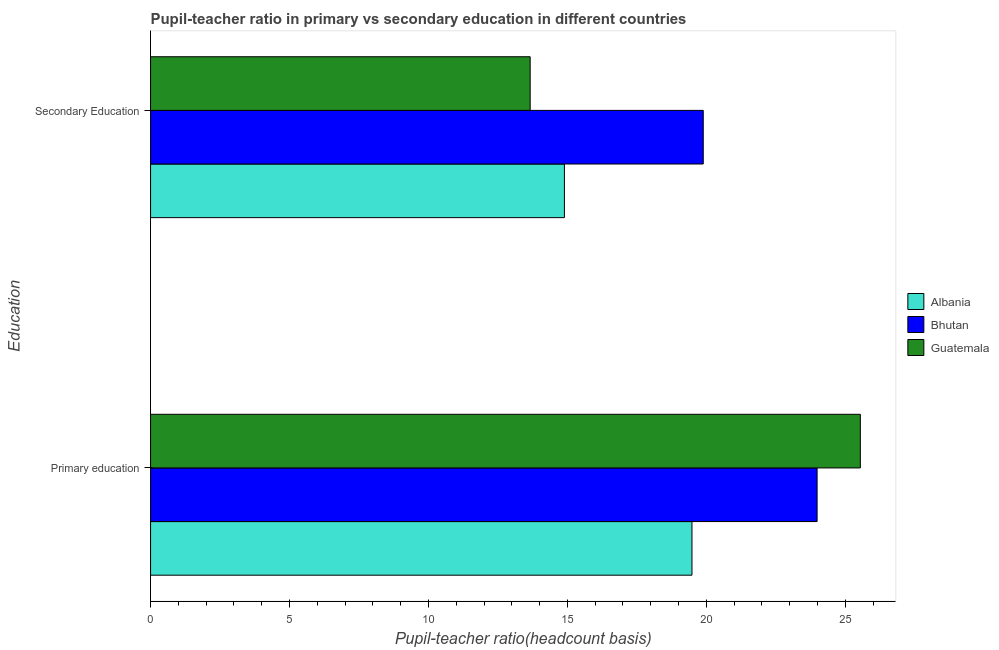How many groups of bars are there?
Your answer should be compact. 2. How many bars are there on the 1st tick from the top?
Your answer should be very brief. 3. What is the label of the 1st group of bars from the top?
Keep it short and to the point. Secondary Education. What is the pupil-teacher ratio in primary education in Albania?
Your answer should be compact. 19.48. Across all countries, what is the maximum pupil-teacher ratio in primary education?
Provide a succinct answer. 25.54. Across all countries, what is the minimum pupil teacher ratio on secondary education?
Your answer should be very brief. 13.66. In which country was the pupil-teacher ratio in primary education maximum?
Provide a succinct answer. Guatemala. In which country was the pupil-teacher ratio in primary education minimum?
Your response must be concise. Albania. What is the total pupil teacher ratio on secondary education in the graph?
Your answer should be compact. 48.44. What is the difference between the pupil teacher ratio on secondary education in Guatemala and that in Albania?
Your answer should be compact. -1.23. What is the difference between the pupil-teacher ratio in primary education in Albania and the pupil teacher ratio on secondary education in Bhutan?
Offer a very short reply. -0.41. What is the average pupil-teacher ratio in primary education per country?
Ensure brevity in your answer.  23. What is the difference between the pupil-teacher ratio in primary education and pupil teacher ratio on secondary education in Albania?
Offer a terse response. 4.59. In how many countries, is the pupil teacher ratio on secondary education greater than 16 ?
Your answer should be very brief. 1. What is the ratio of the pupil teacher ratio on secondary education in Guatemala to that in Bhutan?
Make the answer very short. 0.69. Is the pupil-teacher ratio in primary education in Guatemala less than that in Albania?
Ensure brevity in your answer.  No. What does the 3rd bar from the top in Secondary Education represents?
Offer a terse response. Albania. What does the 2nd bar from the bottom in Primary education represents?
Give a very brief answer. Bhutan. How many bars are there?
Your response must be concise. 6. Are all the bars in the graph horizontal?
Ensure brevity in your answer.  Yes. What is the difference between two consecutive major ticks on the X-axis?
Keep it short and to the point. 5. Are the values on the major ticks of X-axis written in scientific E-notation?
Give a very brief answer. No. Does the graph contain any zero values?
Provide a short and direct response. No. Does the graph contain grids?
Keep it short and to the point. No. How many legend labels are there?
Keep it short and to the point. 3. What is the title of the graph?
Your response must be concise. Pupil-teacher ratio in primary vs secondary education in different countries. Does "Tajikistan" appear as one of the legend labels in the graph?
Make the answer very short. No. What is the label or title of the X-axis?
Keep it short and to the point. Pupil-teacher ratio(headcount basis). What is the label or title of the Y-axis?
Your answer should be very brief. Education. What is the Pupil-teacher ratio(headcount basis) of Albania in Primary education?
Provide a succinct answer. 19.48. What is the Pupil-teacher ratio(headcount basis) of Bhutan in Primary education?
Provide a short and direct response. 23.99. What is the Pupil-teacher ratio(headcount basis) of Guatemala in Primary education?
Provide a succinct answer. 25.54. What is the Pupil-teacher ratio(headcount basis) of Albania in Secondary Education?
Your response must be concise. 14.89. What is the Pupil-teacher ratio(headcount basis) of Bhutan in Secondary Education?
Your answer should be very brief. 19.89. What is the Pupil-teacher ratio(headcount basis) in Guatemala in Secondary Education?
Ensure brevity in your answer.  13.66. Across all Education, what is the maximum Pupil-teacher ratio(headcount basis) of Albania?
Keep it short and to the point. 19.48. Across all Education, what is the maximum Pupil-teacher ratio(headcount basis) of Bhutan?
Provide a short and direct response. 23.99. Across all Education, what is the maximum Pupil-teacher ratio(headcount basis) of Guatemala?
Make the answer very short. 25.54. Across all Education, what is the minimum Pupil-teacher ratio(headcount basis) of Albania?
Make the answer very short. 14.89. Across all Education, what is the minimum Pupil-teacher ratio(headcount basis) of Bhutan?
Your answer should be compact. 19.89. Across all Education, what is the minimum Pupil-teacher ratio(headcount basis) in Guatemala?
Offer a very short reply. 13.66. What is the total Pupil-teacher ratio(headcount basis) of Albania in the graph?
Your answer should be compact. 34.38. What is the total Pupil-teacher ratio(headcount basis) in Bhutan in the graph?
Keep it short and to the point. 43.88. What is the total Pupil-teacher ratio(headcount basis) of Guatemala in the graph?
Your answer should be compact. 39.2. What is the difference between the Pupil-teacher ratio(headcount basis) in Albania in Primary education and that in Secondary Education?
Your response must be concise. 4.59. What is the difference between the Pupil-teacher ratio(headcount basis) of Bhutan in Primary education and that in Secondary Education?
Ensure brevity in your answer.  4.1. What is the difference between the Pupil-teacher ratio(headcount basis) in Guatemala in Primary education and that in Secondary Education?
Provide a short and direct response. 11.88. What is the difference between the Pupil-teacher ratio(headcount basis) of Albania in Primary education and the Pupil-teacher ratio(headcount basis) of Bhutan in Secondary Education?
Provide a succinct answer. -0.41. What is the difference between the Pupil-teacher ratio(headcount basis) in Albania in Primary education and the Pupil-teacher ratio(headcount basis) in Guatemala in Secondary Education?
Offer a very short reply. 5.82. What is the difference between the Pupil-teacher ratio(headcount basis) of Bhutan in Primary education and the Pupil-teacher ratio(headcount basis) of Guatemala in Secondary Education?
Offer a terse response. 10.33. What is the average Pupil-teacher ratio(headcount basis) of Albania per Education?
Your response must be concise. 17.19. What is the average Pupil-teacher ratio(headcount basis) of Bhutan per Education?
Keep it short and to the point. 21.94. What is the average Pupil-teacher ratio(headcount basis) of Guatemala per Education?
Offer a very short reply. 19.6. What is the difference between the Pupil-teacher ratio(headcount basis) in Albania and Pupil-teacher ratio(headcount basis) in Bhutan in Primary education?
Provide a succinct answer. -4.5. What is the difference between the Pupil-teacher ratio(headcount basis) of Albania and Pupil-teacher ratio(headcount basis) of Guatemala in Primary education?
Your response must be concise. -6.06. What is the difference between the Pupil-teacher ratio(headcount basis) in Bhutan and Pupil-teacher ratio(headcount basis) in Guatemala in Primary education?
Offer a terse response. -1.56. What is the difference between the Pupil-teacher ratio(headcount basis) in Albania and Pupil-teacher ratio(headcount basis) in Bhutan in Secondary Education?
Your answer should be compact. -5. What is the difference between the Pupil-teacher ratio(headcount basis) of Albania and Pupil-teacher ratio(headcount basis) of Guatemala in Secondary Education?
Make the answer very short. 1.23. What is the difference between the Pupil-teacher ratio(headcount basis) of Bhutan and Pupil-teacher ratio(headcount basis) of Guatemala in Secondary Education?
Your answer should be very brief. 6.23. What is the ratio of the Pupil-teacher ratio(headcount basis) of Albania in Primary education to that in Secondary Education?
Keep it short and to the point. 1.31. What is the ratio of the Pupil-teacher ratio(headcount basis) of Bhutan in Primary education to that in Secondary Education?
Your answer should be compact. 1.21. What is the ratio of the Pupil-teacher ratio(headcount basis) of Guatemala in Primary education to that in Secondary Education?
Make the answer very short. 1.87. What is the difference between the highest and the second highest Pupil-teacher ratio(headcount basis) in Albania?
Give a very brief answer. 4.59. What is the difference between the highest and the second highest Pupil-teacher ratio(headcount basis) in Bhutan?
Provide a succinct answer. 4.1. What is the difference between the highest and the second highest Pupil-teacher ratio(headcount basis) in Guatemala?
Keep it short and to the point. 11.88. What is the difference between the highest and the lowest Pupil-teacher ratio(headcount basis) in Albania?
Provide a succinct answer. 4.59. What is the difference between the highest and the lowest Pupil-teacher ratio(headcount basis) in Bhutan?
Provide a succinct answer. 4.1. What is the difference between the highest and the lowest Pupil-teacher ratio(headcount basis) in Guatemala?
Ensure brevity in your answer.  11.88. 